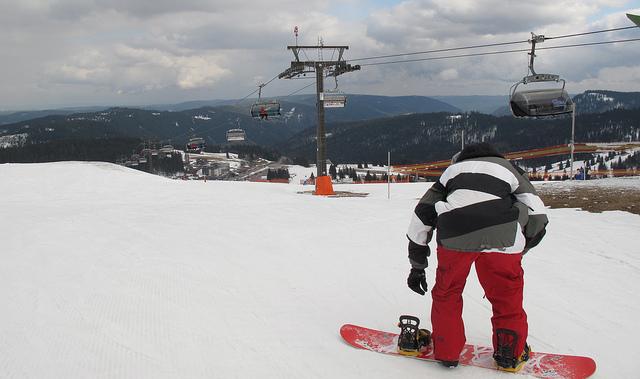What is the temp?
Keep it brief. Cold. What activity are they performing?
Give a very brief answer. Snowboarding. What sport is this?
Keep it brief. Snowboarding. What sport is this person engaging in?
Concise answer only. Snowboarding. Is the snowboard broken?
Concise answer only. No. Why is snow white?
Short answer required. Pure. 